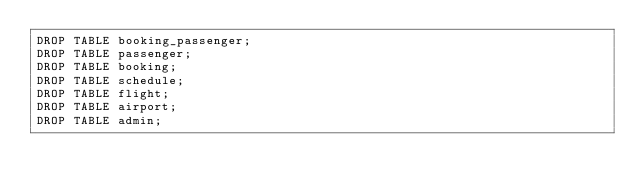<code> <loc_0><loc_0><loc_500><loc_500><_SQL_>DROP TABLE booking_passenger;
DROP TABLE passenger;
DROP TABLE booking;
DROP TABLE schedule;
DROP TABLE flight;
DROP TABLE airport;
DROP TABLE admin;</code> 